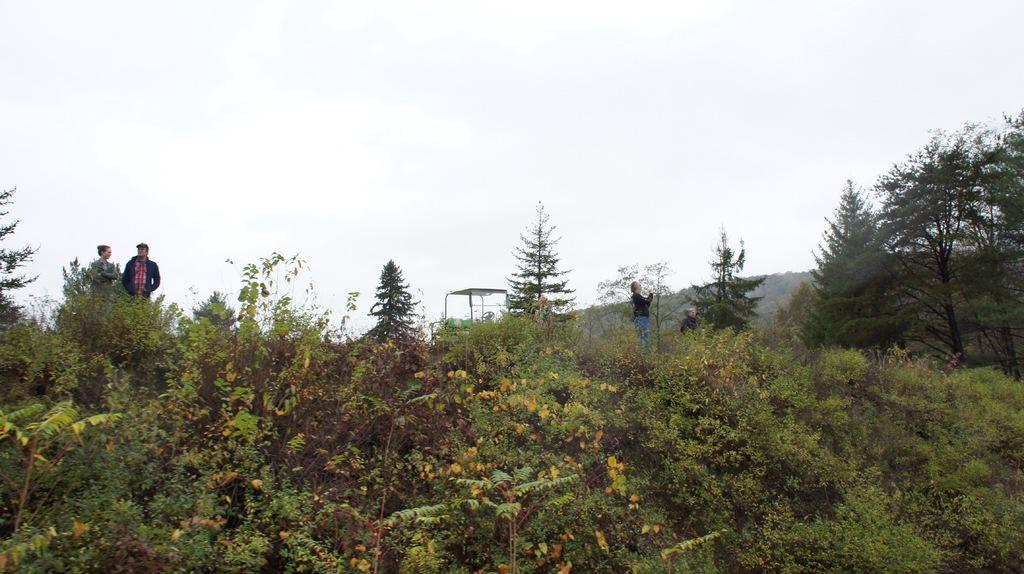What is the main geographical feature in the picture? There is a mountain in the picture. What are the people in the picture doing? There are people standing on the mountain. What type of vegetation can be seen in the picture? There are plants and trees in the picture. What is the condition of the sky in the picture? The sky is clear in the picture. Can you tell me how many tramps are visible in the picture? There are no tramps present in the image; it features a mountain with people standing on it. What type of chain is holding the trees together in the picture? There is no chain holding the trees together in the picture; the trees are standing independently. 